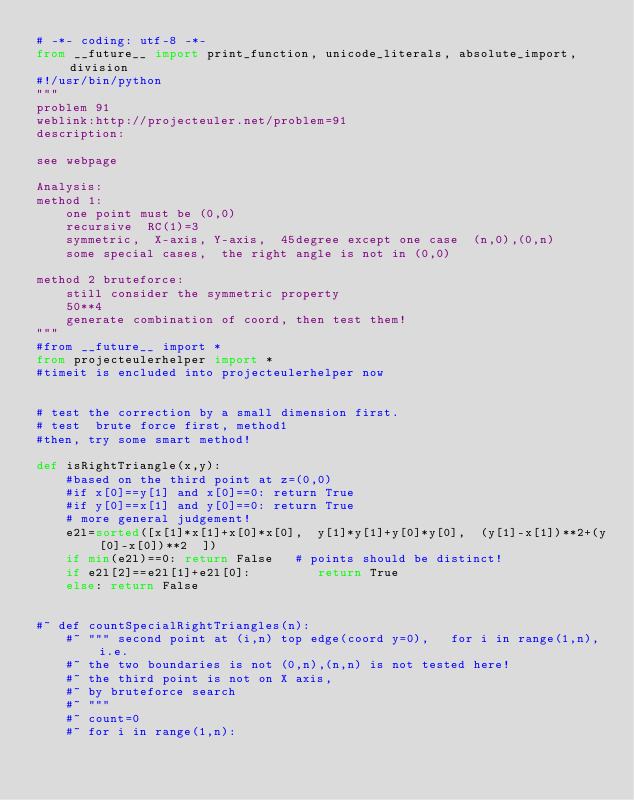Convert code to text. <code><loc_0><loc_0><loc_500><loc_500><_Python_># -*- coding: utf-8 -*-
from __future__ import print_function, unicode_literals, absolute_import, division
#!/usr/bin/python
"""
problem 91
weblink:http://projecteuler.net/problem=91
description:

see webpage

Analysis:
method 1:
    one point must be (0,0)
    recursive  RC(1)=3
    symmetric,  X-axis, Y-axis,  45degree except one case  (n,0),(0,n)
    some special cases,  the right angle is not in (0,0)
    
method 2 bruteforce: 
    still consider the symmetric property
    50**4
    generate combination of coord, then test them!
"""
#from __future__ import *
from projecteulerhelper import *
#timeit is encluded into projecteulerhelper now


# test the correction by a small dimension first. 
# test  brute force first, method1
#then, try some smart method! 

def isRightTriangle(x,y):
    #based on the third point at z=(0,0)
    #if x[0]==y[1] and x[0]==0: return True
    #if y[0]==x[1] and y[0]==0: return True
    # more general judgement!
    e2l=sorted([x[1]*x[1]+x[0]*x[0],  y[1]*y[1]+y[0]*y[0],  (y[1]-x[1])**2+(y[0]-x[0])**2  ])
    if min(e2l)==0: return False   # points should be distinct!
    if e2l[2]==e2l[1]+e2l[0]:         return True
    else: return False
    

#~ def countSpecialRightTriangles(n):
    #~ """ second point at (i,n) top edge(coord y=0),   for i in range(1,n), i.e. 
    #~ the two boundaries is not (0,n),(n,n) is not tested here!
    #~ the third point is not on X axis, 
    #~ by bruteforce search
    #~ """
    #~ count=0
    #~ for i in range(1,n):</code> 